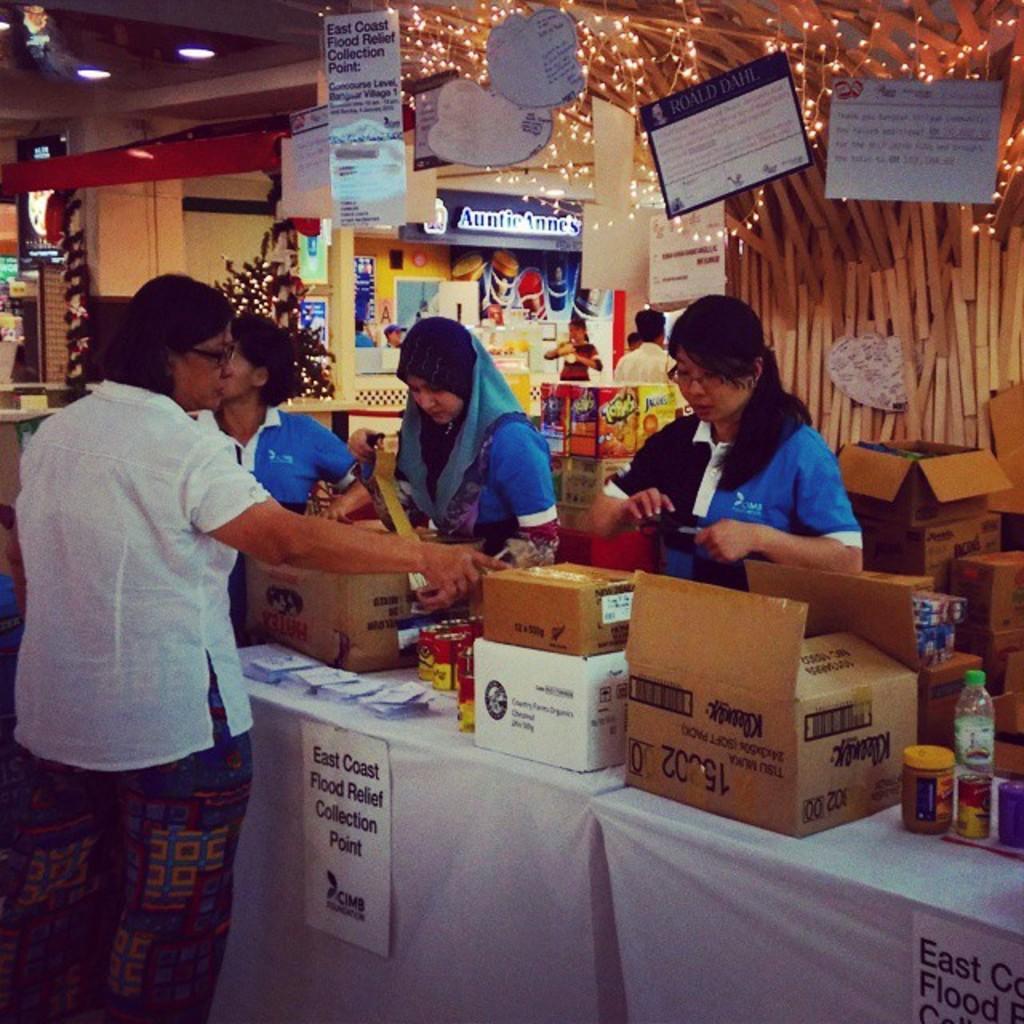Please provide a concise description of this image. In this image there are few people. On the table there are cartons, bottles. On the top there are many cardboards. In the background there is a store. There are lights on the top. On the ceiling there are lights. 